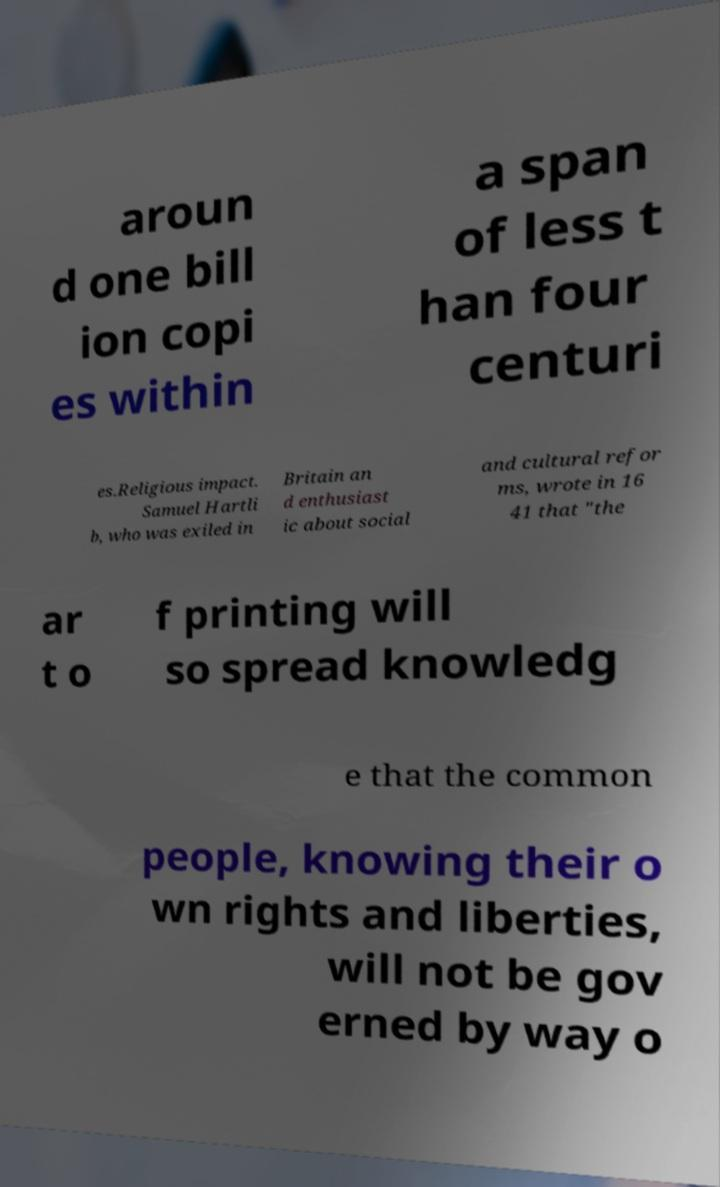I need the written content from this picture converted into text. Can you do that? aroun d one bill ion copi es within a span of less t han four centuri es.Religious impact. Samuel Hartli b, who was exiled in Britain an d enthusiast ic about social and cultural refor ms, wrote in 16 41 that "the ar t o f printing will so spread knowledg e that the common people, knowing their o wn rights and liberties, will not be gov erned by way o 